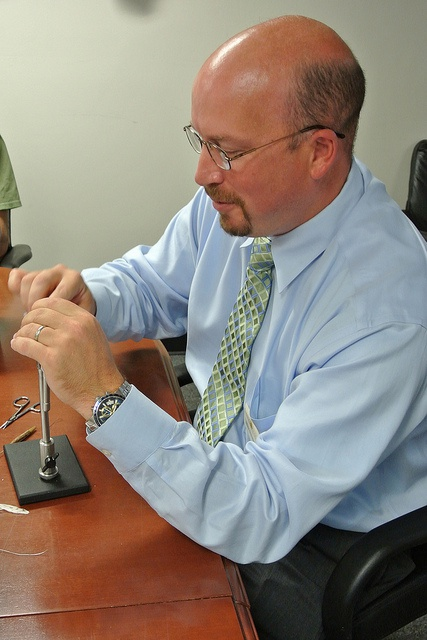Describe the objects in this image and their specific colors. I can see people in beige, darkgray, brown, and black tones, chair in beige, black, and gray tones, tie in beige, darkgray, gray, and olive tones, and chair in beige, black, and gray tones in this image. 